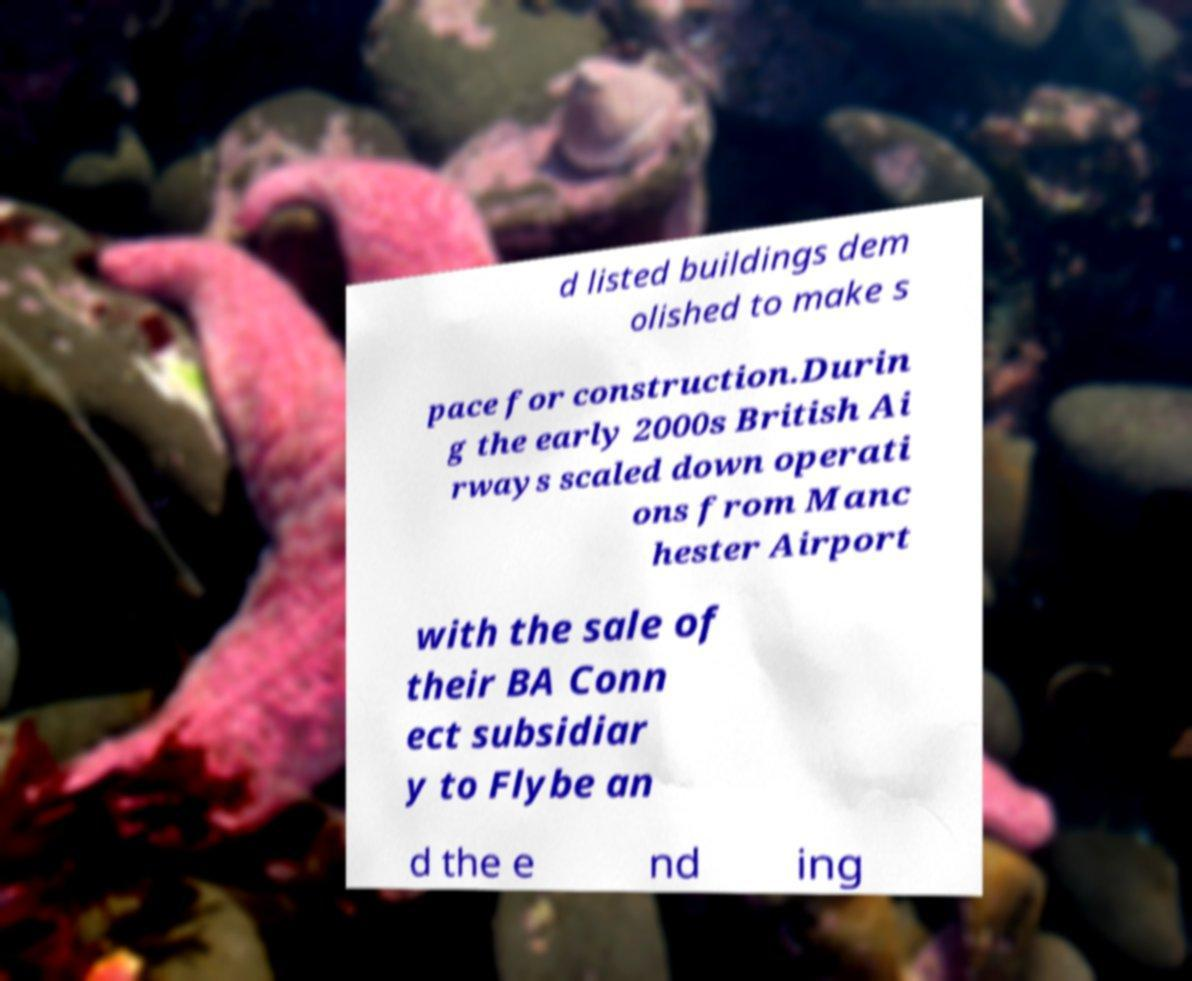What messages or text are displayed in this image? I need them in a readable, typed format. d listed buildings dem olished to make s pace for construction.Durin g the early 2000s British Ai rways scaled down operati ons from Manc hester Airport with the sale of their BA Conn ect subsidiar y to Flybe an d the e nd ing 